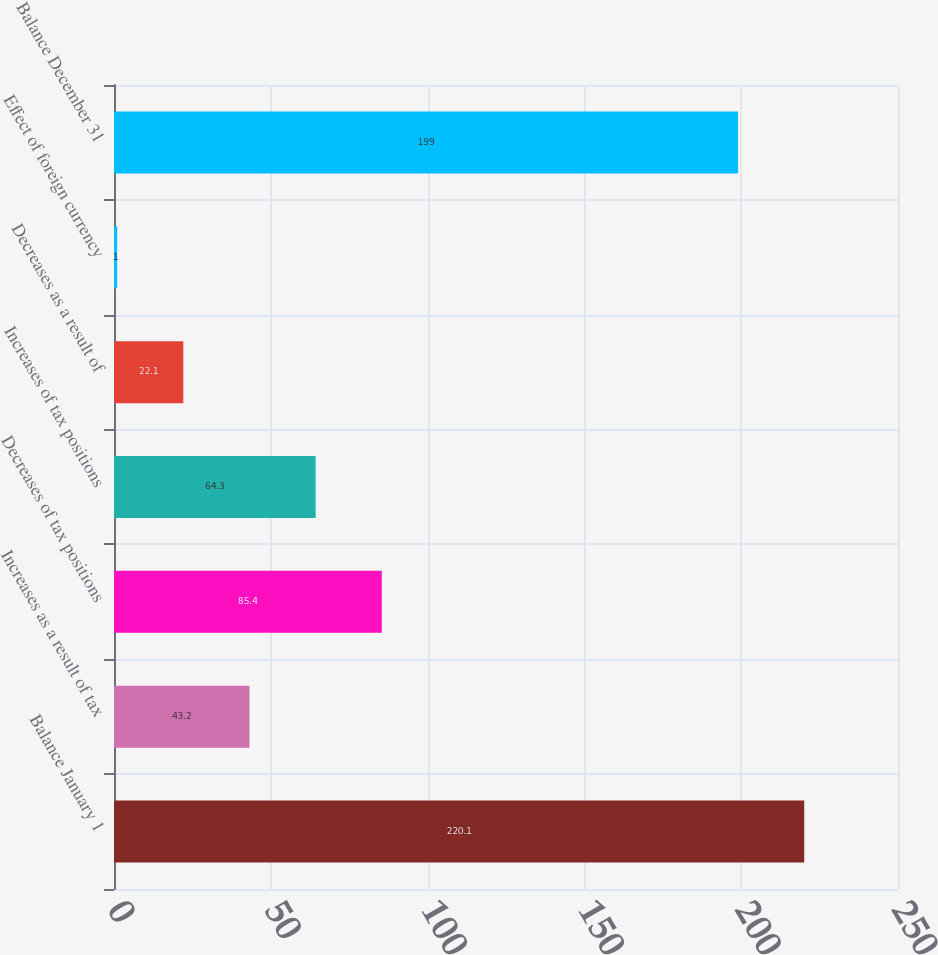Convert chart. <chart><loc_0><loc_0><loc_500><loc_500><bar_chart><fcel>Balance January 1<fcel>Increases as a result of tax<fcel>Decreases of tax positions<fcel>Increases of tax positions<fcel>Decreases as a result of<fcel>Effect of foreign currency<fcel>Balance December 31<nl><fcel>220.1<fcel>43.2<fcel>85.4<fcel>64.3<fcel>22.1<fcel>1<fcel>199<nl></chart> 